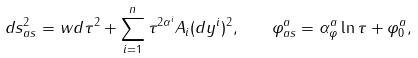Convert formula to latex. <formula><loc_0><loc_0><loc_500><loc_500>d s ^ { 2 } _ { a s } = w d \tau ^ { 2 } + \sum _ { i = 1 } ^ { n } \tau ^ { 2 \alpha ^ { i } } A _ { i } ( d y ^ { i } ) ^ { 2 } , \quad \varphi ^ { a } _ { a s } = \alpha _ { \varphi } ^ { a } \ln \tau + \varphi _ { 0 } ^ { a } ,</formula> 